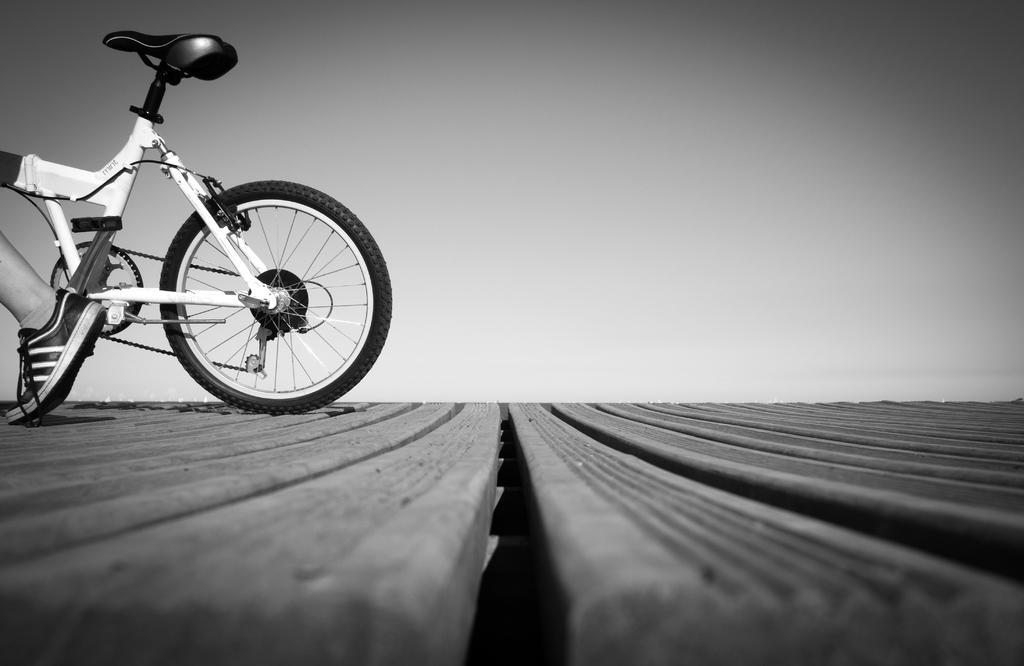What is the color scheme of the image? The image is black and white. What type of surface can be seen in the image? There is a wooden surface in the image. What object is placed on the wooden surface? There is a cycle on the wooden surface. Can you describe any human presence in the image? A leg of a person is visible in front of the cycle. What type of boat is visible in the image? There is no boat present in the image; it features a wooden surface with a cycle and a leg. What kind of error can be seen in the image? There is no error visible in the image; it is a clear representation of a cycle on a wooden surface with a leg nearby. 